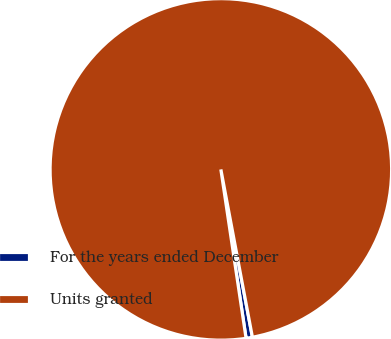<chart> <loc_0><loc_0><loc_500><loc_500><pie_chart><fcel>For the years ended December<fcel>Units granted<nl><fcel>0.6%<fcel>99.4%<nl></chart> 